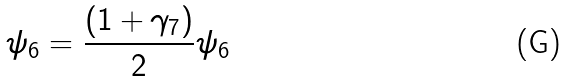Convert formula to latex. <formula><loc_0><loc_0><loc_500><loc_500>\psi _ { 6 } = \frac { \left ( 1 + \gamma _ { 7 } \right ) } { 2 } \psi _ { 6 }</formula> 